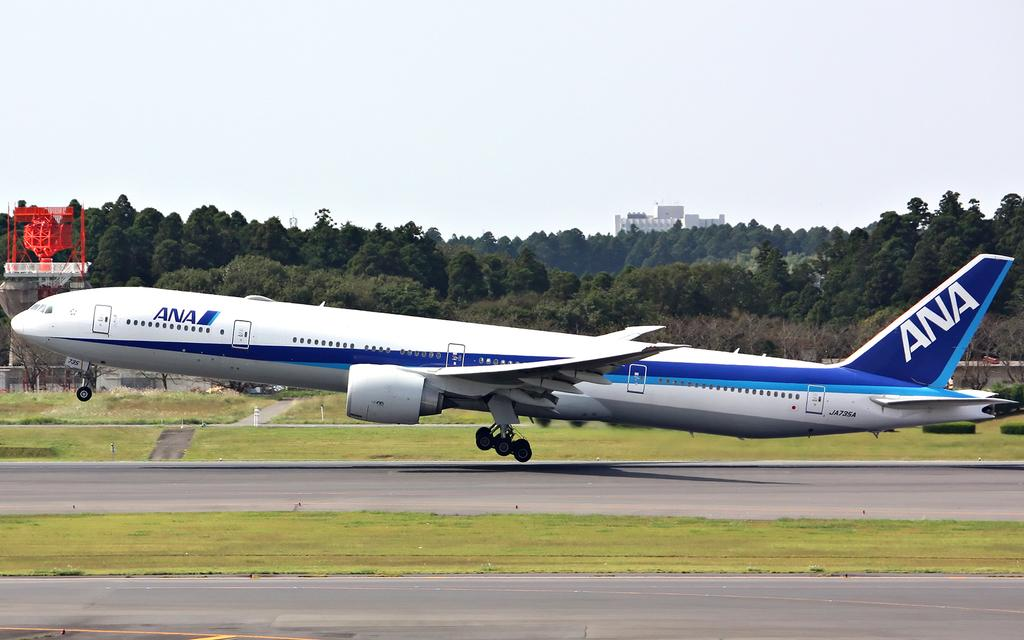Provide a one-sentence caption for the provided image. A blue and white passenger plane with the letters ANA. 